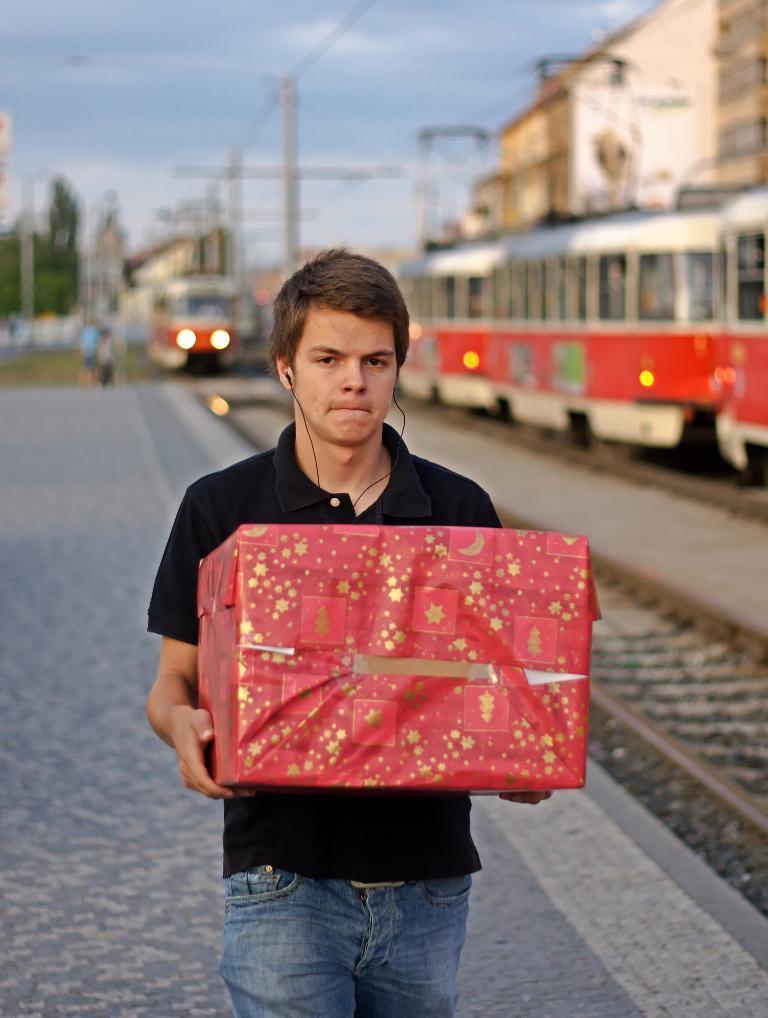Describe this image in one or two sentences. Here I can see a man holding a gift box in the hands and walking on the platform. On the right side there are two trains on the railway tracks. In the background there are many poles, buildings and trees. At the top of the image I can see the sky. 